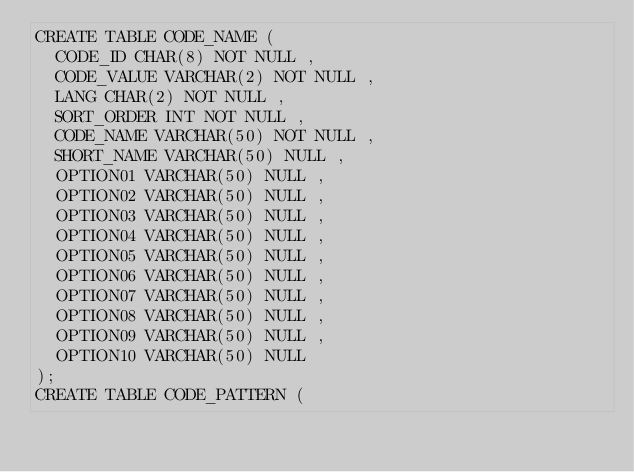Convert code to text. <code><loc_0><loc_0><loc_500><loc_500><_SQL_>CREATE TABLE CODE_NAME (
  CODE_ID CHAR(8) NOT NULL ,
  CODE_VALUE VARCHAR(2) NOT NULL ,
  LANG CHAR(2) NOT NULL ,
  SORT_ORDER INT NOT NULL ,
  CODE_NAME VARCHAR(50) NOT NULL ,
  SHORT_NAME VARCHAR(50) NULL ,
  OPTION01 VARCHAR(50) NULL ,
  OPTION02 VARCHAR(50) NULL ,
  OPTION03 VARCHAR(50) NULL ,
  OPTION04 VARCHAR(50) NULL ,
  OPTION05 VARCHAR(50) NULL ,
  OPTION06 VARCHAR(50) NULL ,
  OPTION07 VARCHAR(50) NULL ,
  OPTION08 VARCHAR(50) NULL ,
  OPTION09 VARCHAR(50) NULL ,
  OPTION10 VARCHAR(50) NULL 
);
CREATE TABLE CODE_PATTERN (</code> 